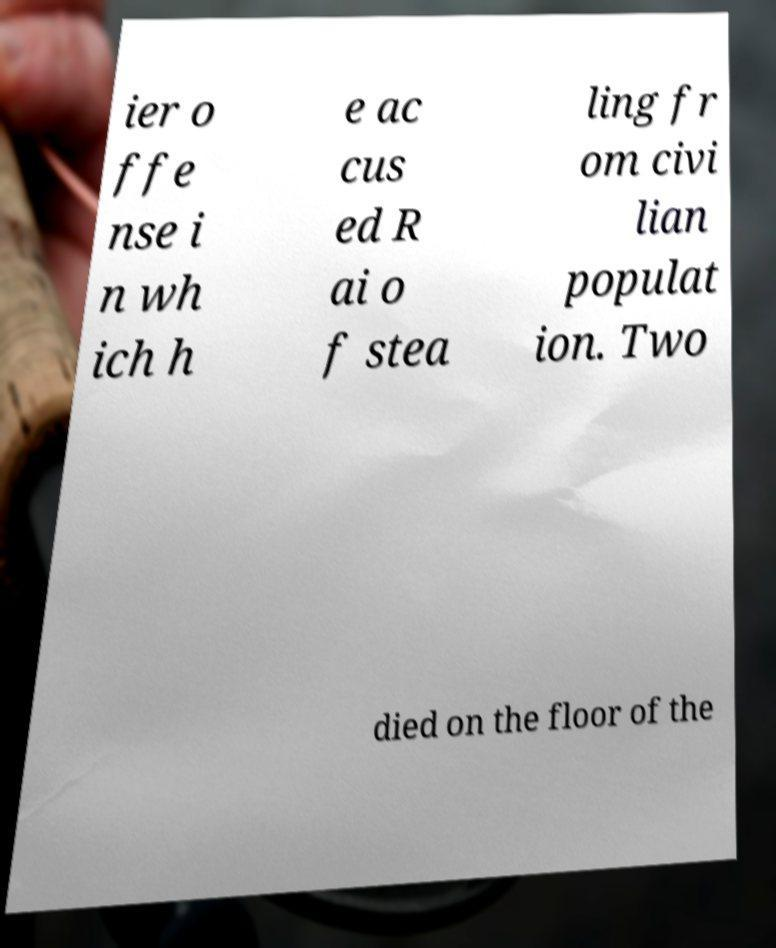What messages or text are displayed in this image? I need them in a readable, typed format. ier o ffe nse i n wh ich h e ac cus ed R ai o f stea ling fr om civi lian populat ion. Two died on the floor of the 